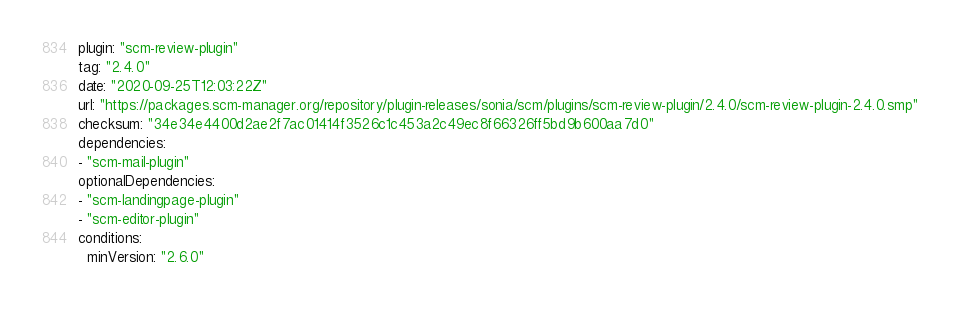<code> <loc_0><loc_0><loc_500><loc_500><_YAML_>plugin: "scm-review-plugin"
tag: "2.4.0"
date: "2020-09-25T12:03:22Z"
url: "https://packages.scm-manager.org/repository/plugin-releases/sonia/scm/plugins/scm-review-plugin/2.4.0/scm-review-plugin-2.4.0.smp"
checksum: "34e34e4400d2ae2f7ac01414f3526c1c453a2c49ec8f66326ff5bd9b600aa7d0"
dependencies:
- "scm-mail-plugin"
optionalDependencies:
- "scm-landingpage-plugin"
- "scm-editor-plugin"
conditions:
  minVersion: "2.6.0"
</code> 